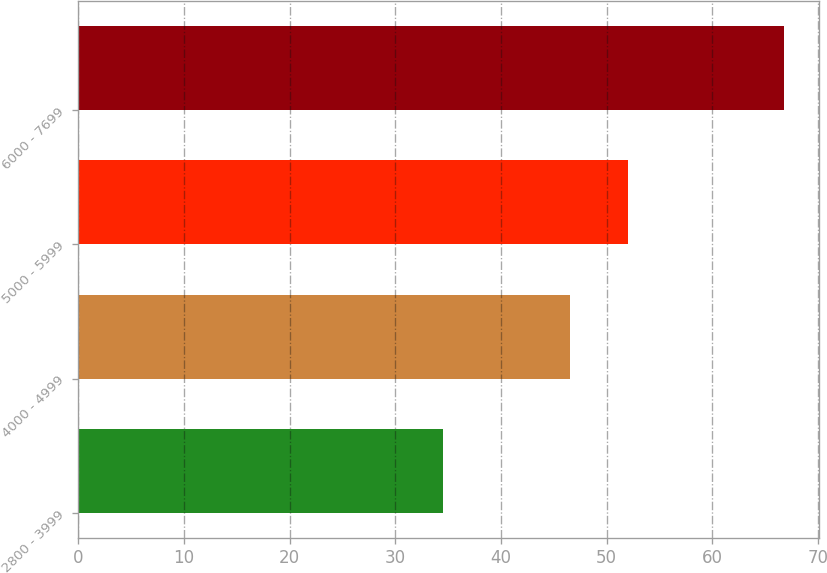Convert chart. <chart><loc_0><loc_0><loc_500><loc_500><bar_chart><fcel>2800 - 3999<fcel>4000 - 4999<fcel>5000 - 5999<fcel>6000 - 7699<nl><fcel>34.5<fcel>46.57<fcel>52.05<fcel>66.75<nl></chart> 